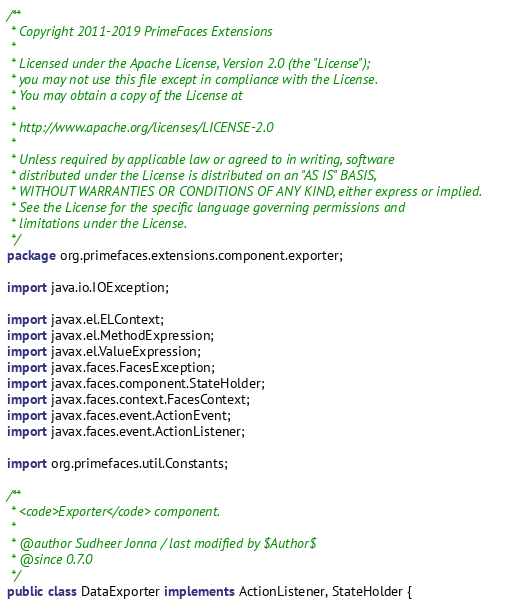Convert code to text. <code><loc_0><loc_0><loc_500><loc_500><_Java_>/**
 * Copyright 2011-2019 PrimeFaces Extensions
 *
 * Licensed under the Apache License, Version 2.0 (the "License");
 * you may not use this file except in compliance with the License.
 * You may obtain a copy of the License at
 *
 * http://www.apache.org/licenses/LICENSE-2.0
 *
 * Unless required by applicable law or agreed to in writing, software
 * distributed under the License is distributed on an "AS IS" BASIS,
 * WITHOUT WARRANTIES OR CONDITIONS OF ANY KIND, either express or implied.
 * See the License for the specific language governing permissions and
 * limitations under the License.
 */
package org.primefaces.extensions.component.exporter;

import java.io.IOException;

import javax.el.ELContext;
import javax.el.MethodExpression;
import javax.el.ValueExpression;
import javax.faces.FacesException;
import javax.faces.component.StateHolder;
import javax.faces.context.FacesContext;
import javax.faces.event.ActionEvent;
import javax.faces.event.ActionListener;

import org.primefaces.util.Constants;

/**
 * <code>Exporter</code> component.
 *
 * @author Sudheer Jonna / last modified by $Author$
 * @since 0.7.0
 */
public class DataExporter implements ActionListener, StateHolder {
</code> 